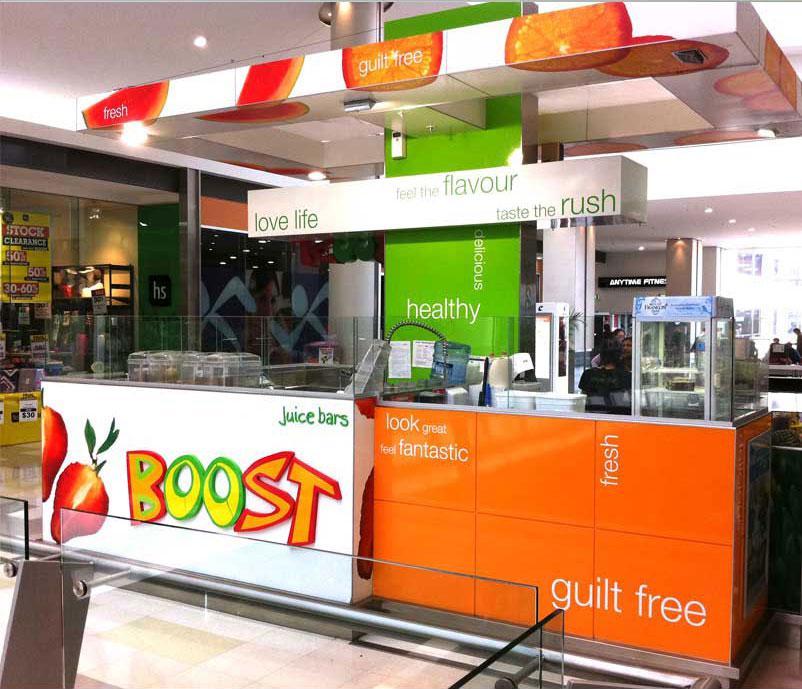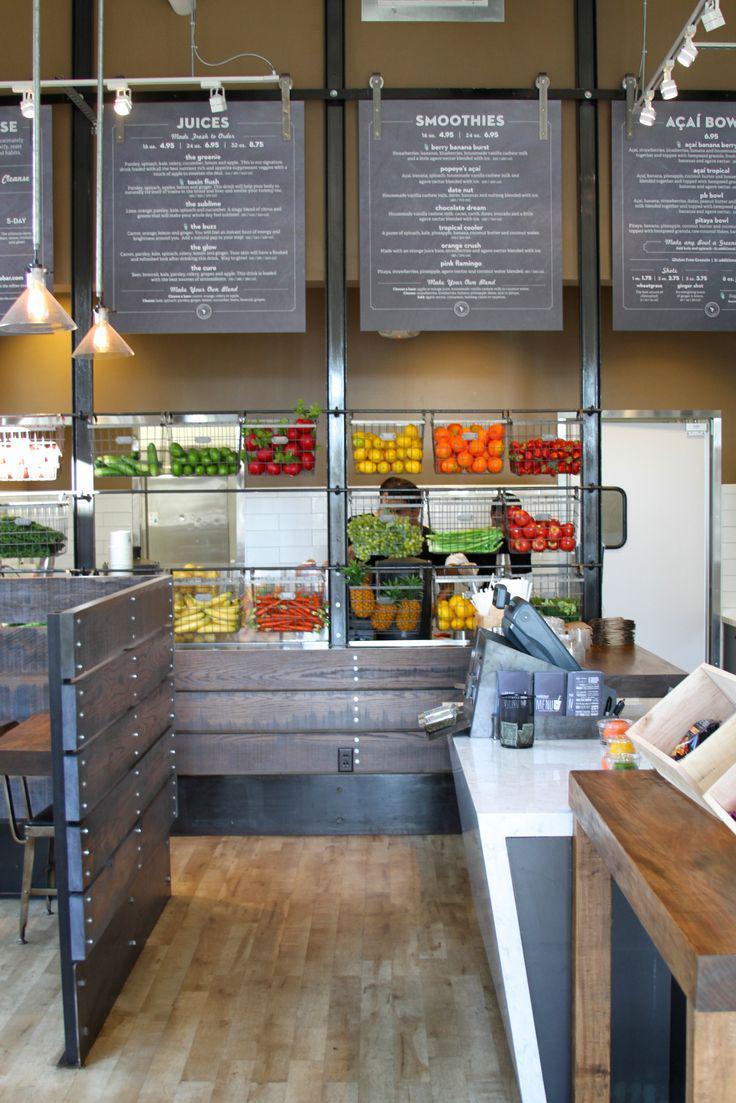The first image is the image on the left, the second image is the image on the right. Assess this claim about the two images: "An image shows the front of an eatery inside a bigger building, with signage that includes bright green color and a red fruit.". Correct or not? Answer yes or no. Yes. 